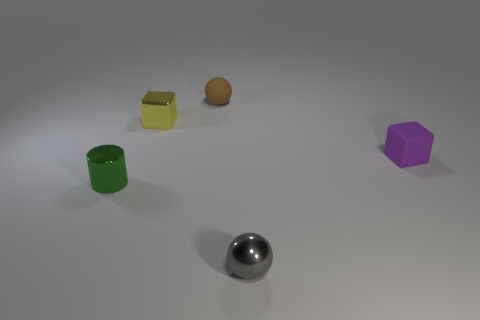What color is the ball behind the cube that is to the right of the yellow metal object?
Make the answer very short. Brown. Is there a tiny matte thing of the same color as the small cylinder?
Provide a succinct answer. No. How many matte things are yellow cubes or big cyan balls?
Your answer should be compact. 0. Are there any balls that have the same material as the tiny green thing?
Your response must be concise. Yes. How many tiny metal things are both right of the yellow thing and behind the shiny cylinder?
Provide a succinct answer. 0. Is the number of metal cubes that are in front of the tiny green metallic thing less than the number of gray spheres that are on the left side of the tiny brown rubber thing?
Ensure brevity in your answer.  No. Does the yellow shiny thing have the same shape as the tiny gray object?
Give a very brief answer. No. How many other things are there of the same size as the metallic cube?
Give a very brief answer. 4. How many things are small things in front of the tiny purple matte block or small things that are to the left of the tiny metallic sphere?
Make the answer very short. 4. What number of other small metal things have the same shape as the green metallic object?
Ensure brevity in your answer.  0. 